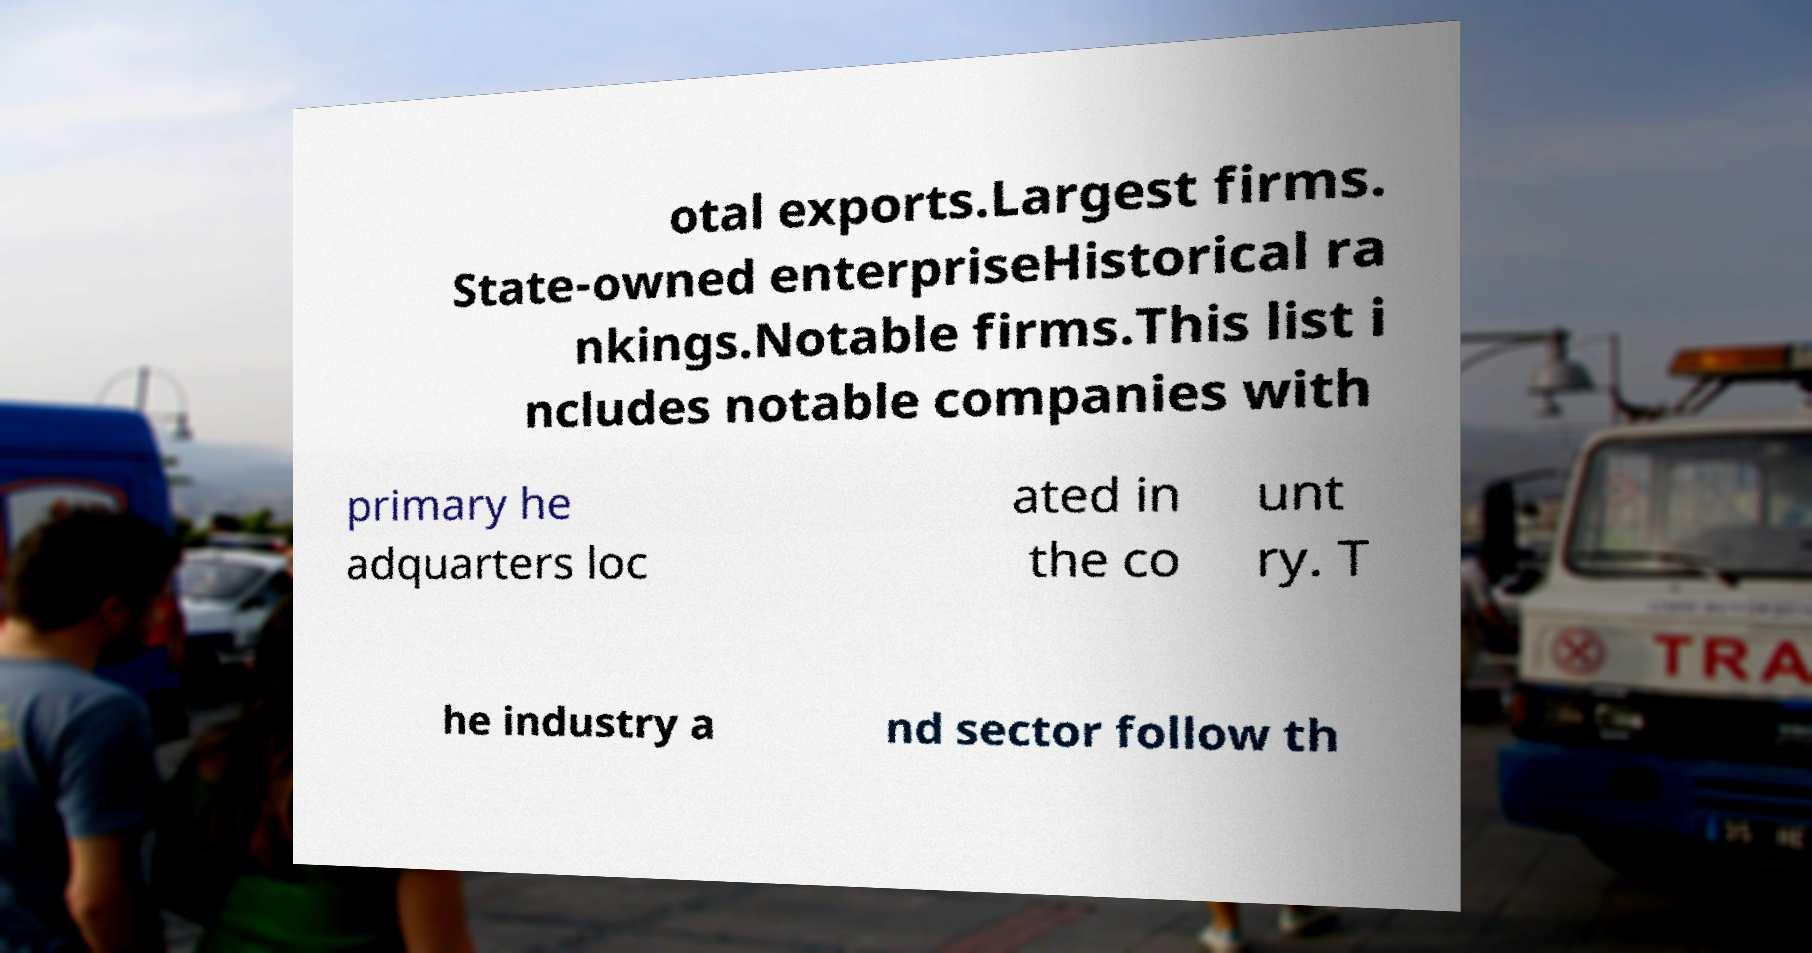For documentation purposes, I need the text within this image transcribed. Could you provide that? otal exports.Largest firms. State-owned enterpriseHistorical ra nkings.Notable firms.This list i ncludes notable companies with primary he adquarters loc ated in the co unt ry. T he industry a nd sector follow th 